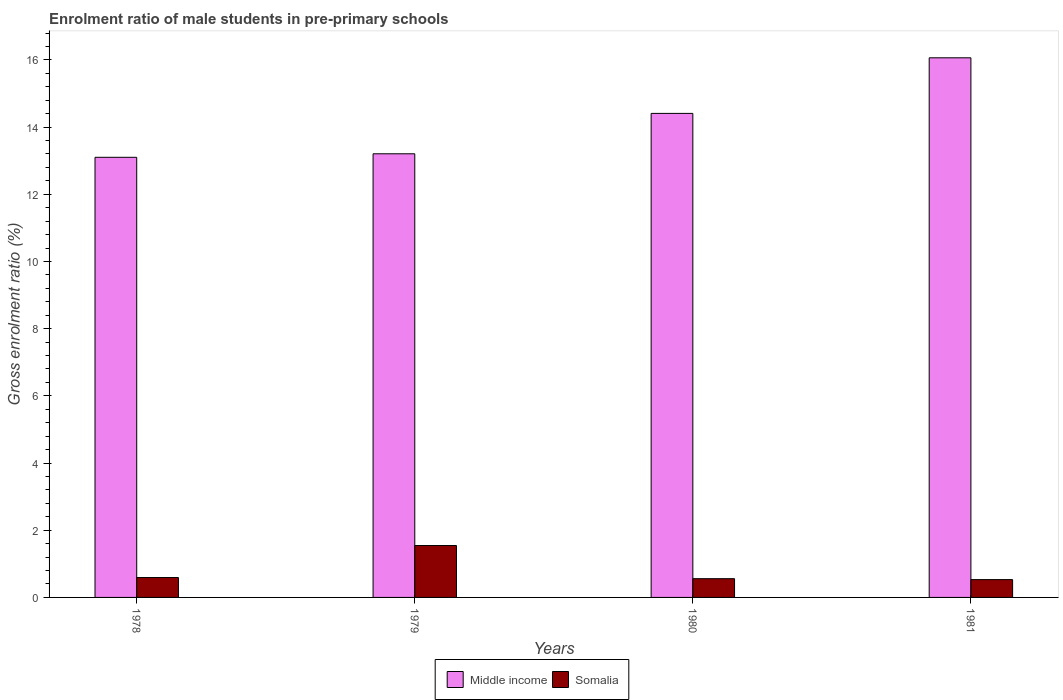How many groups of bars are there?
Provide a succinct answer. 4. Are the number of bars on each tick of the X-axis equal?
Offer a very short reply. Yes. What is the enrolment ratio of male students in pre-primary schools in Middle income in 1978?
Your answer should be compact. 13.1. Across all years, what is the maximum enrolment ratio of male students in pre-primary schools in Middle income?
Offer a very short reply. 16.06. Across all years, what is the minimum enrolment ratio of male students in pre-primary schools in Somalia?
Give a very brief answer. 0.53. What is the total enrolment ratio of male students in pre-primary schools in Somalia in the graph?
Your answer should be very brief. 3.23. What is the difference between the enrolment ratio of male students in pre-primary schools in Somalia in 1978 and that in 1979?
Offer a very short reply. -0.95. What is the difference between the enrolment ratio of male students in pre-primary schools in Middle income in 1981 and the enrolment ratio of male students in pre-primary schools in Somalia in 1978?
Provide a short and direct response. 15.47. What is the average enrolment ratio of male students in pre-primary schools in Somalia per year?
Provide a short and direct response. 0.81. In the year 1979, what is the difference between the enrolment ratio of male students in pre-primary schools in Somalia and enrolment ratio of male students in pre-primary schools in Middle income?
Offer a very short reply. -11.66. What is the ratio of the enrolment ratio of male students in pre-primary schools in Somalia in 1980 to that in 1981?
Give a very brief answer. 1.05. What is the difference between the highest and the second highest enrolment ratio of male students in pre-primary schools in Somalia?
Offer a terse response. 0.95. What is the difference between the highest and the lowest enrolment ratio of male students in pre-primary schools in Middle income?
Provide a succinct answer. 2.96. In how many years, is the enrolment ratio of male students in pre-primary schools in Middle income greater than the average enrolment ratio of male students in pre-primary schools in Middle income taken over all years?
Keep it short and to the point. 2. Is the sum of the enrolment ratio of male students in pre-primary schools in Middle income in 1978 and 1981 greater than the maximum enrolment ratio of male students in pre-primary schools in Somalia across all years?
Offer a terse response. Yes. What does the 1st bar from the right in 1979 represents?
Offer a terse response. Somalia. How many bars are there?
Give a very brief answer. 8. Are the values on the major ticks of Y-axis written in scientific E-notation?
Ensure brevity in your answer.  No. Where does the legend appear in the graph?
Provide a succinct answer. Bottom center. How are the legend labels stacked?
Give a very brief answer. Horizontal. What is the title of the graph?
Provide a succinct answer. Enrolment ratio of male students in pre-primary schools. What is the label or title of the X-axis?
Your answer should be compact. Years. What is the label or title of the Y-axis?
Your answer should be compact. Gross enrolment ratio (%). What is the Gross enrolment ratio (%) in Middle income in 1978?
Provide a short and direct response. 13.1. What is the Gross enrolment ratio (%) of Somalia in 1978?
Your answer should be compact. 0.59. What is the Gross enrolment ratio (%) of Middle income in 1979?
Keep it short and to the point. 13.21. What is the Gross enrolment ratio (%) of Somalia in 1979?
Provide a succinct answer. 1.55. What is the Gross enrolment ratio (%) in Middle income in 1980?
Your answer should be very brief. 14.41. What is the Gross enrolment ratio (%) of Somalia in 1980?
Offer a very short reply. 0.56. What is the Gross enrolment ratio (%) in Middle income in 1981?
Your answer should be very brief. 16.06. What is the Gross enrolment ratio (%) in Somalia in 1981?
Make the answer very short. 0.53. Across all years, what is the maximum Gross enrolment ratio (%) of Middle income?
Offer a very short reply. 16.06. Across all years, what is the maximum Gross enrolment ratio (%) in Somalia?
Make the answer very short. 1.55. Across all years, what is the minimum Gross enrolment ratio (%) of Middle income?
Your answer should be very brief. 13.1. Across all years, what is the minimum Gross enrolment ratio (%) in Somalia?
Provide a succinct answer. 0.53. What is the total Gross enrolment ratio (%) of Middle income in the graph?
Your answer should be very brief. 56.78. What is the total Gross enrolment ratio (%) of Somalia in the graph?
Your response must be concise. 3.23. What is the difference between the Gross enrolment ratio (%) of Middle income in 1978 and that in 1979?
Make the answer very short. -0.1. What is the difference between the Gross enrolment ratio (%) of Somalia in 1978 and that in 1979?
Your answer should be very brief. -0.95. What is the difference between the Gross enrolment ratio (%) of Middle income in 1978 and that in 1980?
Provide a short and direct response. -1.31. What is the difference between the Gross enrolment ratio (%) in Somalia in 1978 and that in 1980?
Your answer should be compact. 0.03. What is the difference between the Gross enrolment ratio (%) in Middle income in 1978 and that in 1981?
Keep it short and to the point. -2.96. What is the difference between the Gross enrolment ratio (%) of Somalia in 1978 and that in 1981?
Offer a terse response. 0.06. What is the difference between the Gross enrolment ratio (%) in Middle income in 1979 and that in 1980?
Your answer should be compact. -1.2. What is the difference between the Gross enrolment ratio (%) in Middle income in 1979 and that in 1981?
Provide a short and direct response. -2.86. What is the difference between the Gross enrolment ratio (%) of Somalia in 1979 and that in 1981?
Give a very brief answer. 1.01. What is the difference between the Gross enrolment ratio (%) of Middle income in 1980 and that in 1981?
Offer a terse response. -1.65. What is the difference between the Gross enrolment ratio (%) of Somalia in 1980 and that in 1981?
Offer a very short reply. 0.03. What is the difference between the Gross enrolment ratio (%) in Middle income in 1978 and the Gross enrolment ratio (%) in Somalia in 1979?
Your response must be concise. 11.56. What is the difference between the Gross enrolment ratio (%) in Middle income in 1978 and the Gross enrolment ratio (%) in Somalia in 1980?
Offer a terse response. 12.54. What is the difference between the Gross enrolment ratio (%) in Middle income in 1978 and the Gross enrolment ratio (%) in Somalia in 1981?
Ensure brevity in your answer.  12.57. What is the difference between the Gross enrolment ratio (%) in Middle income in 1979 and the Gross enrolment ratio (%) in Somalia in 1980?
Provide a short and direct response. 12.65. What is the difference between the Gross enrolment ratio (%) of Middle income in 1979 and the Gross enrolment ratio (%) of Somalia in 1981?
Offer a very short reply. 12.68. What is the difference between the Gross enrolment ratio (%) of Middle income in 1980 and the Gross enrolment ratio (%) of Somalia in 1981?
Make the answer very short. 13.88. What is the average Gross enrolment ratio (%) in Middle income per year?
Your response must be concise. 14.19. What is the average Gross enrolment ratio (%) in Somalia per year?
Provide a succinct answer. 0.81. In the year 1978, what is the difference between the Gross enrolment ratio (%) in Middle income and Gross enrolment ratio (%) in Somalia?
Offer a very short reply. 12.51. In the year 1979, what is the difference between the Gross enrolment ratio (%) in Middle income and Gross enrolment ratio (%) in Somalia?
Offer a terse response. 11.66. In the year 1980, what is the difference between the Gross enrolment ratio (%) in Middle income and Gross enrolment ratio (%) in Somalia?
Offer a very short reply. 13.85. In the year 1981, what is the difference between the Gross enrolment ratio (%) in Middle income and Gross enrolment ratio (%) in Somalia?
Offer a very short reply. 15.53. What is the ratio of the Gross enrolment ratio (%) in Middle income in 1978 to that in 1979?
Provide a succinct answer. 0.99. What is the ratio of the Gross enrolment ratio (%) of Somalia in 1978 to that in 1979?
Provide a succinct answer. 0.38. What is the ratio of the Gross enrolment ratio (%) in Middle income in 1978 to that in 1980?
Give a very brief answer. 0.91. What is the ratio of the Gross enrolment ratio (%) in Somalia in 1978 to that in 1980?
Keep it short and to the point. 1.06. What is the ratio of the Gross enrolment ratio (%) of Middle income in 1978 to that in 1981?
Make the answer very short. 0.82. What is the ratio of the Gross enrolment ratio (%) in Somalia in 1978 to that in 1981?
Offer a terse response. 1.12. What is the ratio of the Gross enrolment ratio (%) of Middle income in 1979 to that in 1980?
Give a very brief answer. 0.92. What is the ratio of the Gross enrolment ratio (%) in Somalia in 1979 to that in 1980?
Offer a very short reply. 2.77. What is the ratio of the Gross enrolment ratio (%) in Middle income in 1979 to that in 1981?
Your answer should be compact. 0.82. What is the ratio of the Gross enrolment ratio (%) in Somalia in 1979 to that in 1981?
Your response must be concise. 2.91. What is the ratio of the Gross enrolment ratio (%) of Middle income in 1980 to that in 1981?
Keep it short and to the point. 0.9. What is the ratio of the Gross enrolment ratio (%) in Somalia in 1980 to that in 1981?
Provide a succinct answer. 1.05. What is the difference between the highest and the second highest Gross enrolment ratio (%) in Middle income?
Your response must be concise. 1.65. What is the difference between the highest and the second highest Gross enrolment ratio (%) of Somalia?
Make the answer very short. 0.95. What is the difference between the highest and the lowest Gross enrolment ratio (%) in Middle income?
Provide a short and direct response. 2.96. What is the difference between the highest and the lowest Gross enrolment ratio (%) in Somalia?
Your answer should be compact. 1.01. 